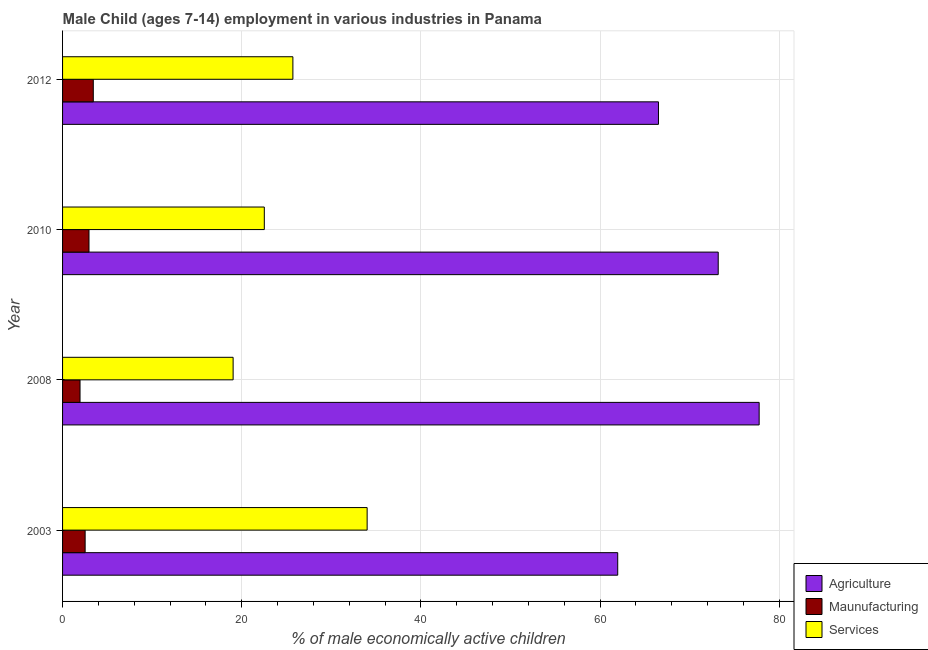Are the number of bars on each tick of the Y-axis equal?
Keep it short and to the point. Yes. What is the percentage of economically active children in services in 2003?
Your response must be concise. 34. Across all years, what is the maximum percentage of economically active children in manufacturing?
Give a very brief answer. 3.43. Across all years, what is the minimum percentage of economically active children in manufacturing?
Offer a terse response. 1.95. In which year was the percentage of economically active children in manufacturing minimum?
Offer a terse response. 2008. What is the total percentage of economically active children in agriculture in the graph?
Offer a terse response. 279.44. What is the difference between the percentage of economically active children in manufacturing in 2003 and that in 2008?
Provide a succinct answer. 0.57. What is the difference between the percentage of economically active children in manufacturing in 2010 and the percentage of economically active children in agriculture in 2008?
Give a very brief answer. -74.81. What is the average percentage of economically active children in manufacturing per year?
Give a very brief answer. 2.71. In the year 2003, what is the difference between the percentage of economically active children in agriculture and percentage of economically active children in manufacturing?
Offer a terse response. 59.45. What is the ratio of the percentage of economically active children in services in 2003 to that in 2012?
Give a very brief answer. 1.32. What is the difference between the highest and the second highest percentage of economically active children in services?
Your answer should be compact. 8.29. What is the difference between the highest and the lowest percentage of economically active children in services?
Your answer should be compact. 14.96. Is the sum of the percentage of economically active children in services in 2008 and 2010 greater than the maximum percentage of economically active children in manufacturing across all years?
Offer a very short reply. Yes. What does the 2nd bar from the top in 2012 represents?
Provide a succinct answer. Maunufacturing. What does the 1st bar from the bottom in 2012 represents?
Make the answer very short. Agriculture. How many bars are there?
Give a very brief answer. 12. Are all the bars in the graph horizontal?
Provide a succinct answer. Yes. What is the difference between two consecutive major ticks on the X-axis?
Offer a very short reply. 20. Are the values on the major ticks of X-axis written in scientific E-notation?
Keep it short and to the point. No. Does the graph contain any zero values?
Your response must be concise. No. Where does the legend appear in the graph?
Provide a succinct answer. Bottom right. How are the legend labels stacked?
Make the answer very short. Vertical. What is the title of the graph?
Ensure brevity in your answer.  Male Child (ages 7-14) employment in various industries in Panama. Does "Ages 20-50" appear as one of the legend labels in the graph?
Your answer should be compact. No. What is the label or title of the X-axis?
Offer a very short reply. % of male economically active children. What is the % of male economically active children in Agriculture in 2003?
Your answer should be very brief. 61.97. What is the % of male economically active children in Maunufacturing in 2003?
Offer a very short reply. 2.52. What is the % of male economically active children of Services in 2003?
Provide a short and direct response. 34. What is the % of male economically active children of Agriculture in 2008?
Provide a short and direct response. 77.76. What is the % of male economically active children of Maunufacturing in 2008?
Make the answer very short. 1.95. What is the % of male economically active children of Services in 2008?
Your response must be concise. 19.04. What is the % of male economically active children of Agriculture in 2010?
Your response must be concise. 73.19. What is the % of male economically active children of Maunufacturing in 2010?
Keep it short and to the point. 2.95. What is the % of male economically active children in Services in 2010?
Your answer should be very brief. 22.52. What is the % of male economically active children in Agriculture in 2012?
Offer a very short reply. 66.52. What is the % of male economically active children in Maunufacturing in 2012?
Provide a short and direct response. 3.43. What is the % of male economically active children in Services in 2012?
Provide a succinct answer. 25.71. Across all years, what is the maximum % of male economically active children in Agriculture?
Give a very brief answer. 77.76. Across all years, what is the maximum % of male economically active children in Maunufacturing?
Your response must be concise. 3.43. Across all years, what is the maximum % of male economically active children of Services?
Ensure brevity in your answer.  34. Across all years, what is the minimum % of male economically active children in Agriculture?
Your answer should be very brief. 61.97. Across all years, what is the minimum % of male economically active children in Maunufacturing?
Your answer should be compact. 1.95. Across all years, what is the minimum % of male economically active children in Services?
Give a very brief answer. 19.04. What is the total % of male economically active children in Agriculture in the graph?
Make the answer very short. 279.44. What is the total % of male economically active children in Maunufacturing in the graph?
Your response must be concise. 10.85. What is the total % of male economically active children of Services in the graph?
Your response must be concise. 101.27. What is the difference between the % of male economically active children of Agriculture in 2003 and that in 2008?
Your answer should be very brief. -15.79. What is the difference between the % of male economically active children in Maunufacturing in 2003 and that in 2008?
Your response must be concise. 0.57. What is the difference between the % of male economically active children of Services in 2003 and that in 2008?
Provide a short and direct response. 14.96. What is the difference between the % of male economically active children in Agriculture in 2003 and that in 2010?
Provide a succinct answer. -11.22. What is the difference between the % of male economically active children in Maunufacturing in 2003 and that in 2010?
Your answer should be very brief. -0.43. What is the difference between the % of male economically active children in Services in 2003 and that in 2010?
Your answer should be very brief. 11.48. What is the difference between the % of male economically active children of Agriculture in 2003 and that in 2012?
Offer a terse response. -4.55. What is the difference between the % of male economically active children in Maunufacturing in 2003 and that in 2012?
Offer a terse response. -0.91. What is the difference between the % of male economically active children in Services in 2003 and that in 2012?
Your answer should be compact. 8.29. What is the difference between the % of male economically active children in Agriculture in 2008 and that in 2010?
Ensure brevity in your answer.  4.57. What is the difference between the % of male economically active children of Maunufacturing in 2008 and that in 2010?
Your answer should be very brief. -1. What is the difference between the % of male economically active children in Services in 2008 and that in 2010?
Your answer should be very brief. -3.48. What is the difference between the % of male economically active children of Agriculture in 2008 and that in 2012?
Your answer should be very brief. 11.24. What is the difference between the % of male economically active children of Maunufacturing in 2008 and that in 2012?
Keep it short and to the point. -1.48. What is the difference between the % of male economically active children in Services in 2008 and that in 2012?
Offer a terse response. -6.67. What is the difference between the % of male economically active children of Agriculture in 2010 and that in 2012?
Provide a succinct answer. 6.67. What is the difference between the % of male economically active children of Maunufacturing in 2010 and that in 2012?
Your answer should be compact. -0.48. What is the difference between the % of male economically active children in Services in 2010 and that in 2012?
Offer a very short reply. -3.19. What is the difference between the % of male economically active children of Agriculture in 2003 and the % of male economically active children of Maunufacturing in 2008?
Offer a terse response. 60.02. What is the difference between the % of male economically active children in Agriculture in 2003 and the % of male economically active children in Services in 2008?
Provide a succinct answer. 42.93. What is the difference between the % of male economically active children in Maunufacturing in 2003 and the % of male economically active children in Services in 2008?
Your response must be concise. -16.52. What is the difference between the % of male economically active children in Agriculture in 2003 and the % of male economically active children in Maunufacturing in 2010?
Keep it short and to the point. 59.02. What is the difference between the % of male economically active children in Agriculture in 2003 and the % of male economically active children in Services in 2010?
Give a very brief answer. 39.45. What is the difference between the % of male economically active children in Maunufacturing in 2003 and the % of male economically active children in Services in 2010?
Your response must be concise. -20. What is the difference between the % of male economically active children in Agriculture in 2003 and the % of male economically active children in Maunufacturing in 2012?
Your response must be concise. 58.54. What is the difference between the % of male economically active children of Agriculture in 2003 and the % of male economically active children of Services in 2012?
Provide a succinct answer. 36.26. What is the difference between the % of male economically active children in Maunufacturing in 2003 and the % of male economically active children in Services in 2012?
Your answer should be very brief. -23.19. What is the difference between the % of male economically active children in Agriculture in 2008 and the % of male economically active children in Maunufacturing in 2010?
Your response must be concise. 74.81. What is the difference between the % of male economically active children in Agriculture in 2008 and the % of male economically active children in Services in 2010?
Offer a very short reply. 55.24. What is the difference between the % of male economically active children of Maunufacturing in 2008 and the % of male economically active children of Services in 2010?
Offer a very short reply. -20.57. What is the difference between the % of male economically active children in Agriculture in 2008 and the % of male economically active children in Maunufacturing in 2012?
Give a very brief answer. 74.33. What is the difference between the % of male economically active children of Agriculture in 2008 and the % of male economically active children of Services in 2012?
Provide a succinct answer. 52.05. What is the difference between the % of male economically active children in Maunufacturing in 2008 and the % of male economically active children in Services in 2012?
Provide a short and direct response. -23.76. What is the difference between the % of male economically active children of Agriculture in 2010 and the % of male economically active children of Maunufacturing in 2012?
Offer a terse response. 69.76. What is the difference between the % of male economically active children in Agriculture in 2010 and the % of male economically active children in Services in 2012?
Your answer should be compact. 47.48. What is the difference between the % of male economically active children of Maunufacturing in 2010 and the % of male economically active children of Services in 2012?
Keep it short and to the point. -22.76. What is the average % of male economically active children of Agriculture per year?
Keep it short and to the point. 69.86. What is the average % of male economically active children in Maunufacturing per year?
Provide a succinct answer. 2.71. What is the average % of male economically active children in Services per year?
Your answer should be very brief. 25.32. In the year 2003, what is the difference between the % of male economically active children of Agriculture and % of male economically active children of Maunufacturing?
Give a very brief answer. 59.45. In the year 2003, what is the difference between the % of male economically active children of Agriculture and % of male economically active children of Services?
Offer a terse response. 27.97. In the year 2003, what is the difference between the % of male economically active children of Maunufacturing and % of male economically active children of Services?
Offer a terse response. -31.48. In the year 2008, what is the difference between the % of male economically active children in Agriculture and % of male economically active children in Maunufacturing?
Make the answer very short. 75.81. In the year 2008, what is the difference between the % of male economically active children of Agriculture and % of male economically active children of Services?
Give a very brief answer. 58.72. In the year 2008, what is the difference between the % of male economically active children in Maunufacturing and % of male economically active children in Services?
Your answer should be compact. -17.09. In the year 2010, what is the difference between the % of male economically active children in Agriculture and % of male economically active children in Maunufacturing?
Ensure brevity in your answer.  70.24. In the year 2010, what is the difference between the % of male economically active children of Agriculture and % of male economically active children of Services?
Your response must be concise. 50.67. In the year 2010, what is the difference between the % of male economically active children of Maunufacturing and % of male economically active children of Services?
Provide a short and direct response. -19.57. In the year 2012, what is the difference between the % of male economically active children in Agriculture and % of male economically active children in Maunufacturing?
Keep it short and to the point. 63.09. In the year 2012, what is the difference between the % of male economically active children in Agriculture and % of male economically active children in Services?
Ensure brevity in your answer.  40.81. In the year 2012, what is the difference between the % of male economically active children of Maunufacturing and % of male economically active children of Services?
Provide a short and direct response. -22.28. What is the ratio of the % of male economically active children in Agriculture in 2003 to that in 2008?
Your answer should be very brief. 0.8. What is the ratio of the % of male economically active children in Maunufacturing in 2003 to that in 2008?
Offer a terse response. 1.29. What is the ratio of the % of male economically active children of Services in 2003 to that in 2008?
Your answer should be very brief. 1.79. What is the ratio of the % of male economically active children in Agriculture in 2003 to that in 2010?
Give a very brief answer. 0.85. What is the ratio of the % of male economically active children of Maunufacturing in 2003 to that in 2010?
Offer a very short reply. 0.85. What is the ratio of the % of male economically active children of Services in 2003 to that in 2010?
Provide a succinct answer. 1.51. What is the ratio of the % of male economically active children in Agriculture in 2003 to that in 2012?
Your answer should be very brief. 0.93. What is the ratio of the % of male economically active children in Maunufacturing in 2003 to that in 2012?
Give a very brief answer. 0.73. What is the ratio of the % of male economically active children in Services in 2003 to that in 2012?
Ensure brevity in your answer.  1.32. What is the ratio of the % of male economically active children in Agriculture in 2008 to that in 2010?
Make the answer very short. 1.06. What is the ratio of the % of male economically active children in Maunufacturing in 2008 to that in 2010?
Make the answer very short. 0.66. What is the ratio of the % of male economically active children in Services in 2008 to that in 2010?
Make the answer very short. 0.85. What is the ratio of the % of male economically active children of Agriculture in 2008 to that in 2012?
Offer a terse response. 1.17. What is the ratio of the % of male economically active children in Maunufacturing in 2008 to that in 2012?
Keep it short and to the point. 0.57. What is the ratio of the % of male economically active children in Services in 2008 to that in 2012?
Your answer should be compact. 0.74. What is the ratio of the % of male economically active children in Agriculture in 2010 to that in 2012?
Ensure brevity in your answer.  1.1. What is the ratio of the % of male economically active children in Maunufacturing in 2010 to that in 2012?
Provide a short and direct response. 0.86. What is the ratio of the % of male economically active children in Services in 2010 to that in 2012?
Ensure brevity in your answer.  0.88. What is the difference between the highest and the second highest % of male economically active children in Agriculture?
Provide a short and direct response. 4.57. What is the difference between the highest and the second highest % of male economically active children of Maunufacturing?
Give a very brief answer. 0.48. What is the difference between the highest and the second highest % of male economically active children of Services?
Keep it short and to the point. 8.29. What is the difference between the highest and the lowest % of male economically active children of Agriculture?
Make the answer very short. 15.79. What is the difference between the highest and the lowest % of male economically active children in Maunufacturing?
Make the answer very short. 1.48. What is the difference between the highest and the lowest % of male economically active children of Services?
Your answer should be very brief. 14.96. 